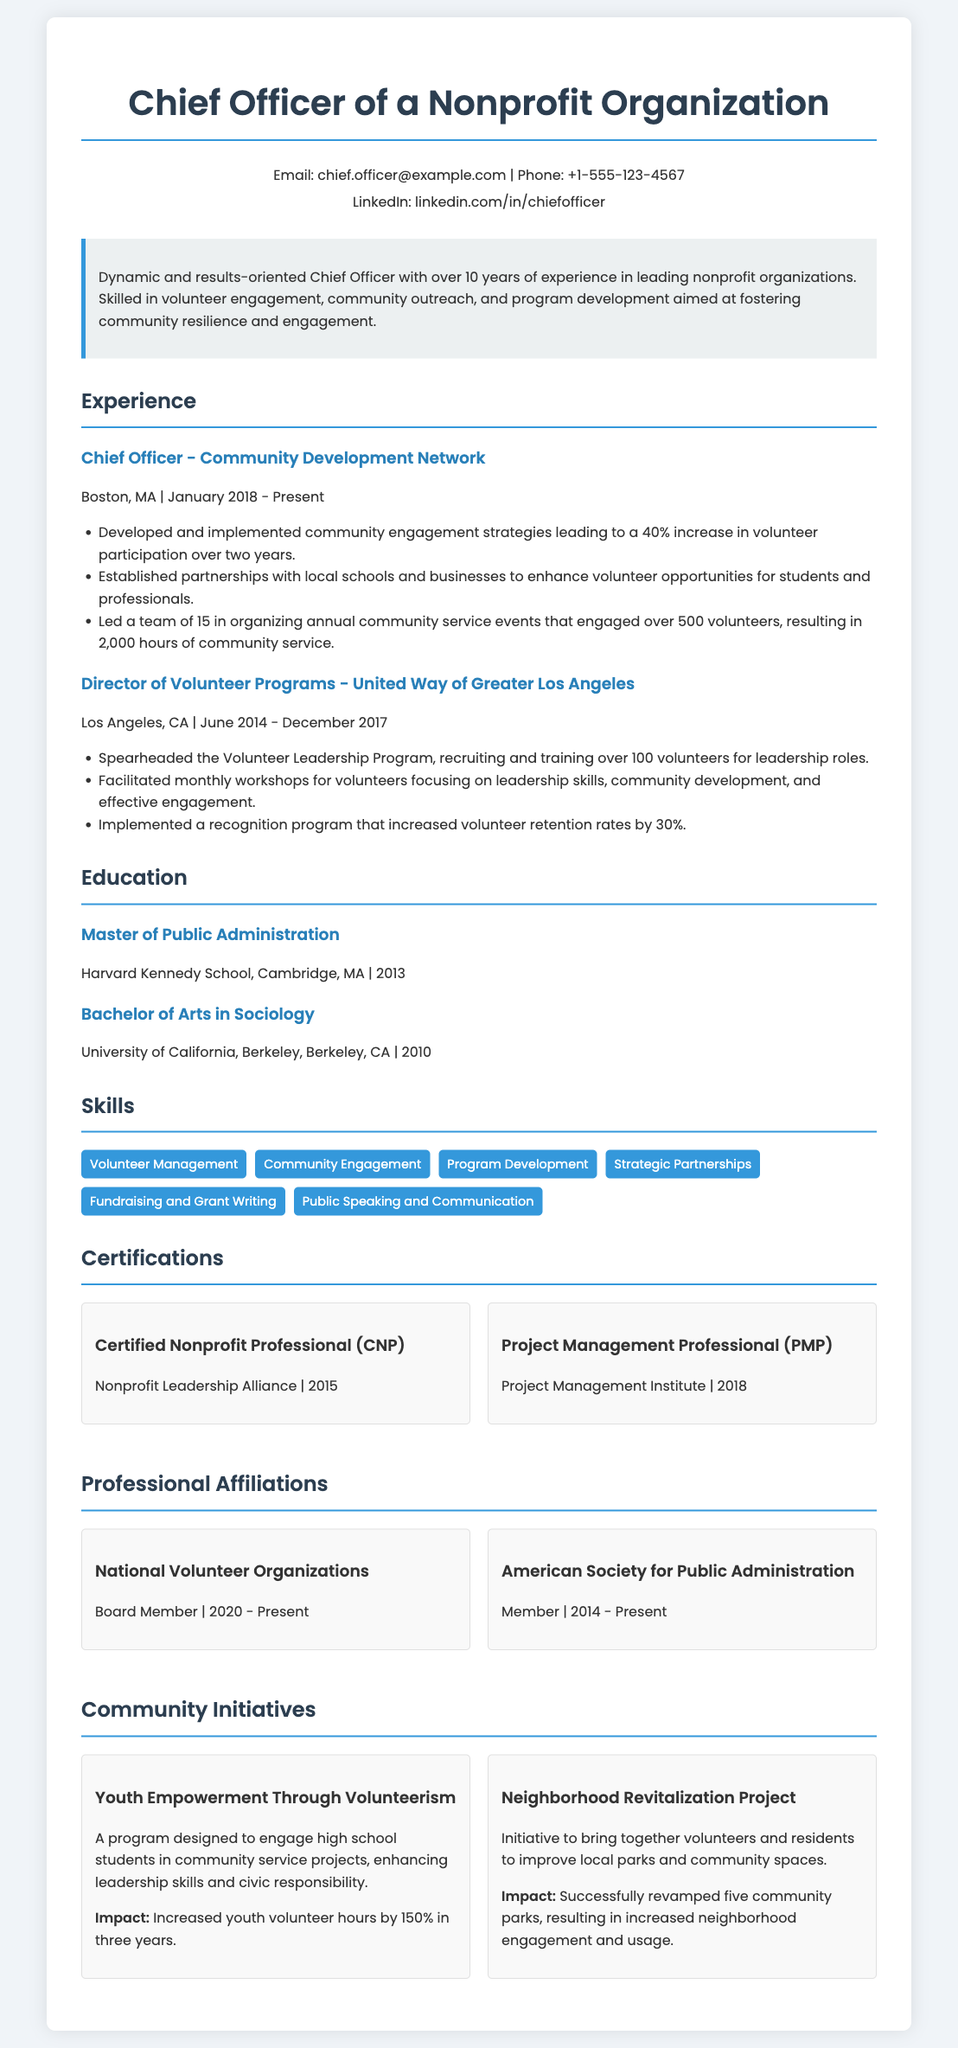what is the current position held? The current position is mentioned in the experience section as Chief Officer at Community Development Network.
Answer: Chief Officer what is the location of the current job? The job location is specified under the current position.
Answer: Boston, MA how many years of experience does the Chief Officer have? The summary states over 10 years of experience in leading nonprofit organizations.
Answer: Over 10 years what was the impact of the Youth Empowerment Through Volunteerism program? The impact is quantified in the document as increased youth volunteer hours by 150%.
Answer: 150% how many volunteers were engaged in the annual community service events? The experience section mentions that over 500 volunteers were engaged.
Answer: Over 500 volunteers what is the name of the initiative aimed at neighborhood improvement? The document lists the initiative as the Neighborhood Revitalization Project.
Answer: Neighborhood Revitalization Project which certification was obtained in 2018? The certifications section specifies the Project Management Professional as obtained in 2018.
Answer: Project Management Professional what was the increase in volunteer retention rates due to the recognition program? The document states that the recognition program increased retention rates by 30%.
Answer: 30% who is a board member of the National Volunteer Organizations? The document states the Chief Officer is a board member.
Answer: Chief Officer 